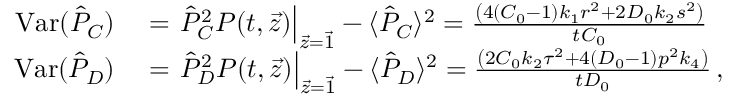Convert formula to latex. <formula><loc_0><loc_0><loc_500><loc_500>\begin{array} { r l } { V a r ( \hat { P } _ { C } ) } & = \hat { P } _ { C } ^ { 2 } P ( t , \vec { z } ) \right | _ { \vec { z } = \vec { 1 } } - \langle \hat { P } _ { C } \rangle ^ { 2 } = \frac { \left ( 4 ( C _ { 0 } - 1 ) k _ { 1 } r ^ { 2 } + 2 D _ { 0 } k _ { 2 } s ^ { 2 } \right ) } { t C _ { 0 } } } \\ { V a r ( \hat { P } _ { D } ) } & = \hat { P } _ { D } ^ { 2 } P ( t , \vec { z } ) \right | _ { \vec { z } = \vec { 1 } } - \langle \hat { P } _ { D } \rangle ^ { 2 } = \frac { \left ( 2 C _ { 0 } k _ { 2 } \tau ^ { 2 } + 4 ( D _ { 0 } - 1 ) p ^ { 2 } k _ { 4 } \right ) } { t D _ { 0 } } \, , } \end{array}</formula> 